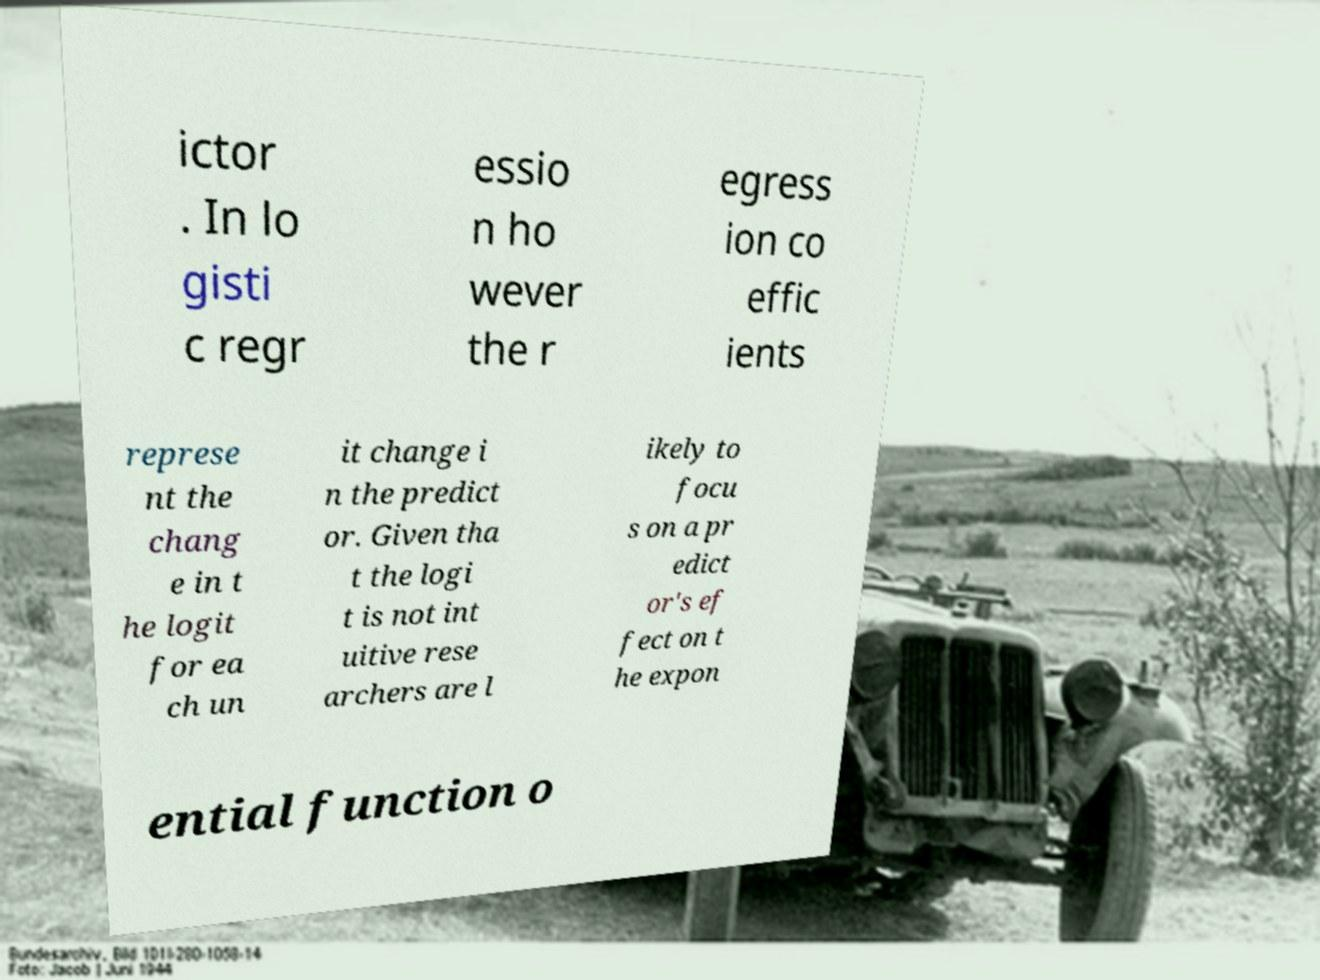There's text embedded in this image that I need extracted. Can you transcribe it verbatim? ictor . In lo gisti c regr essio n ho wever the r egress ion co effic ients represe nt the chang e in t he logit for ea ch un it change i n the predict or. Given tha t the logi t is not int uitive rese archers are l ikely to focu s on a pr edict or's ef fect on t he expon ential function o 